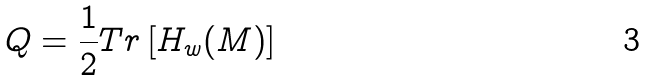Convert formula to latex. <formula><loc_0><loc_0><loc_500><loc_500>Q = \frac { 1 } { 2 } T r \left [ H _ { w } ( M ) \right ]</formula> 